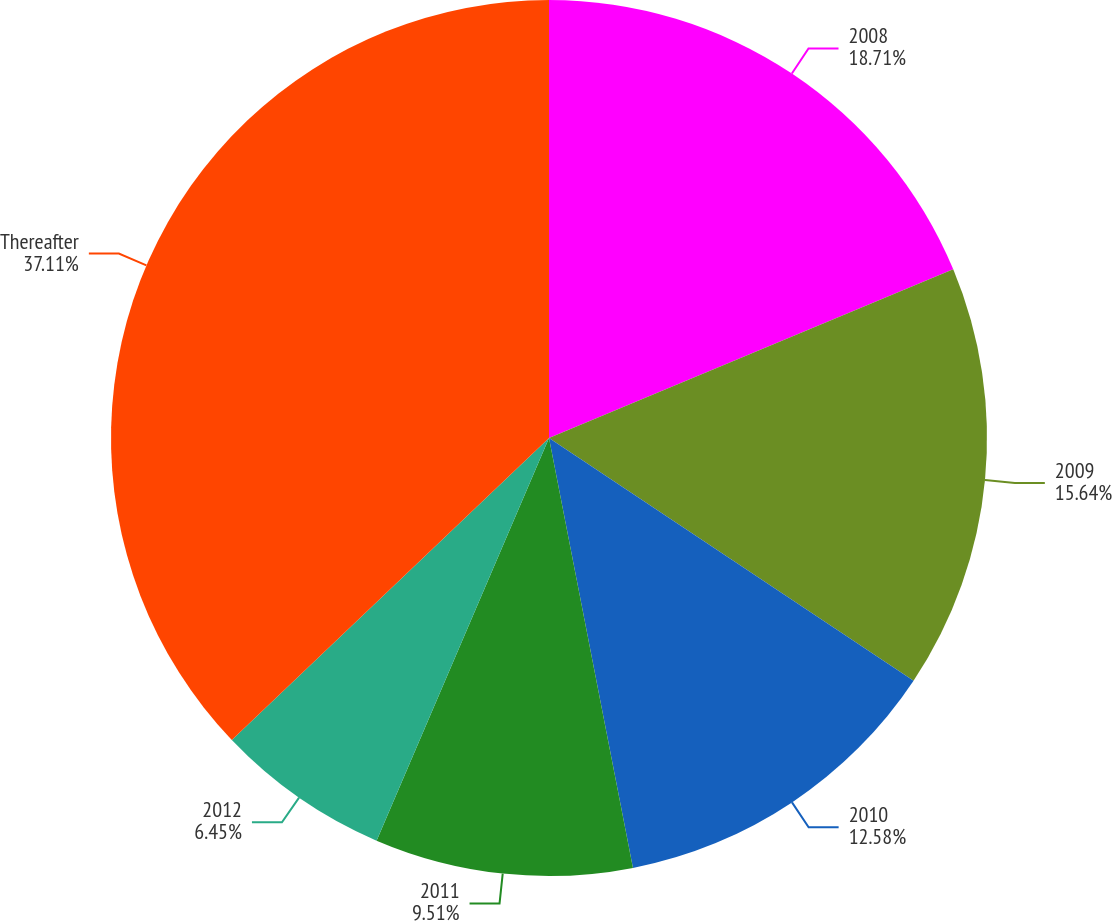Convert chart to OTSL. <chart><loc_0><loc_0><loc_500><loc_500><pie_chart><fcel>2008<fcel>2009<fcel>2010<fcel>2011<fcel>2012<fcel>Thereafter<nl><fcel>18.71%<fcel>15.64%<fcel>12.58%<fcel>9.51%<fcel>6.45%<fcel>37.11%<nl></chart> 